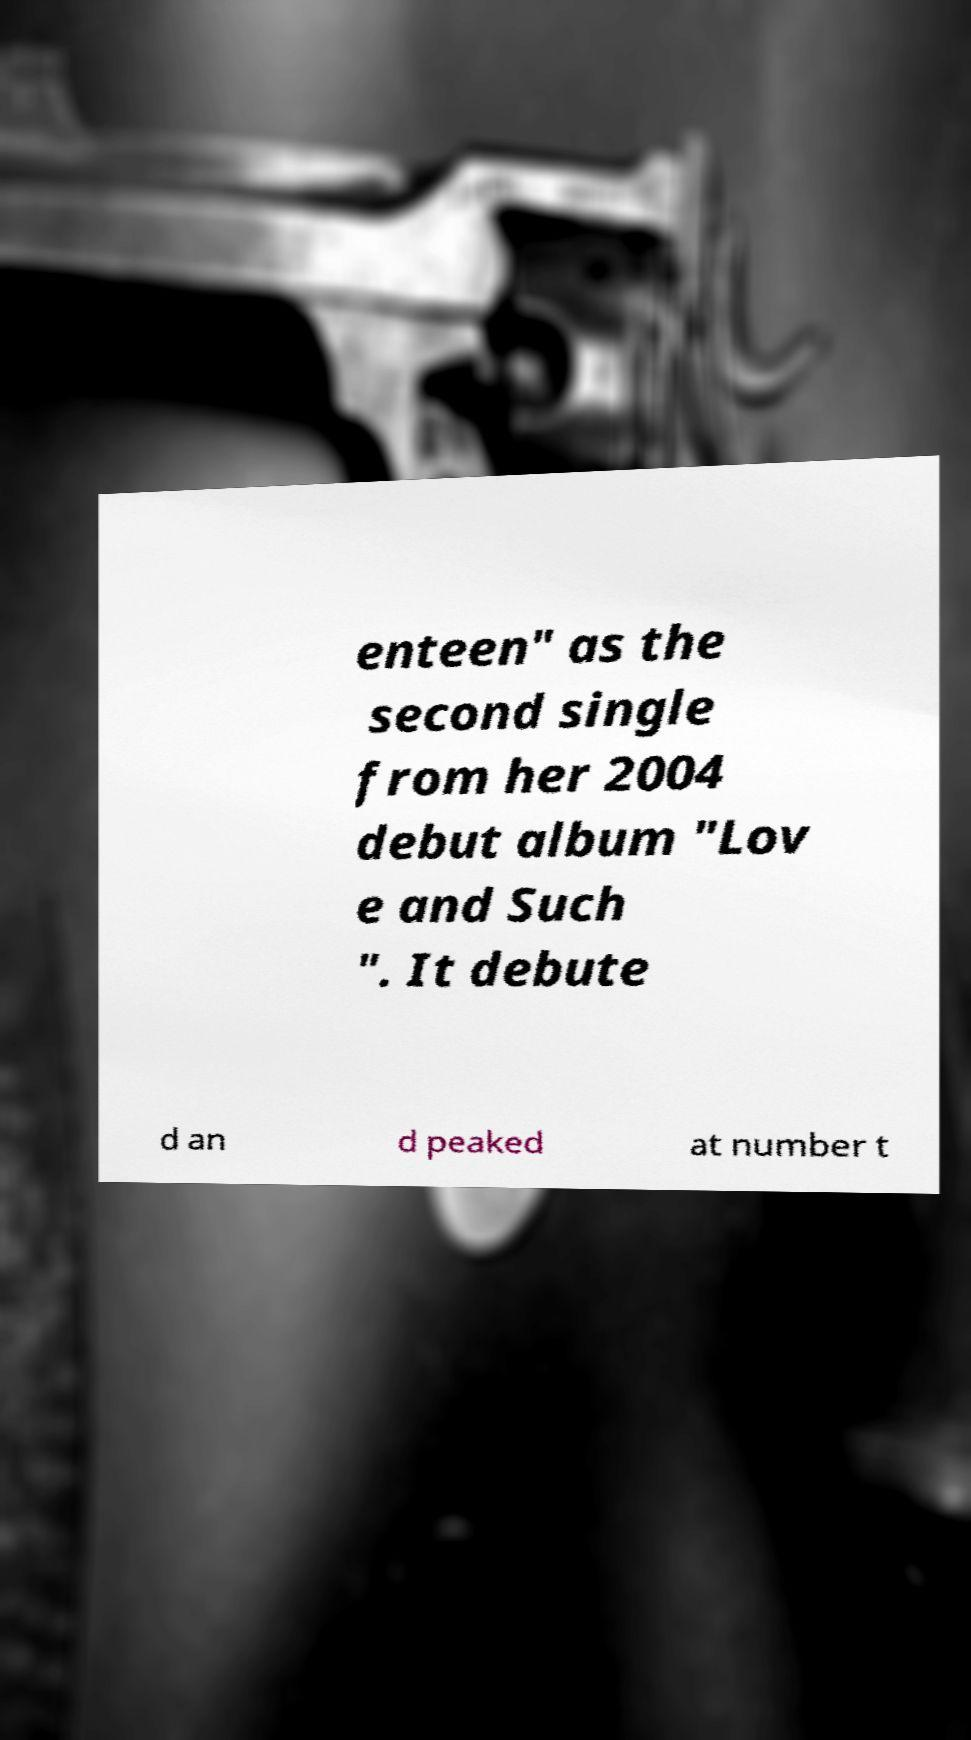Can you accurately transcribe the text from the provided image for me? enteen" as the second single from her 2004 debut album "Lov e and Such ". It debute d an d peaked at number t 